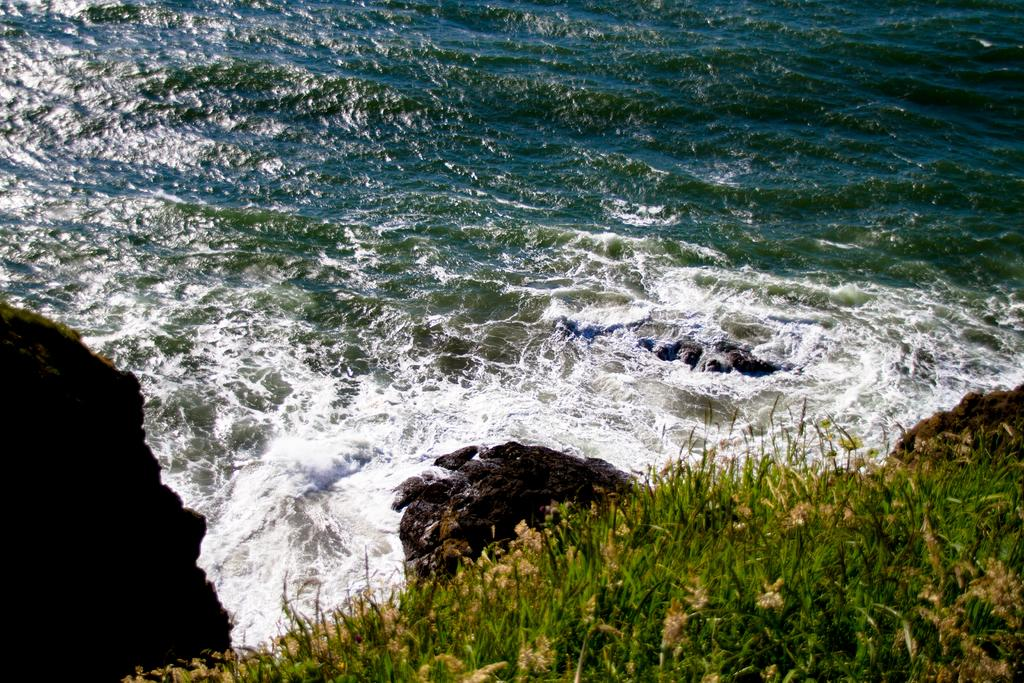What celestial bodies are shown in the image? There are planets depicted in the image. Where are the planets located in the image? The planets are at the bottom of the image. What can be seen in the background of the image? There is water visible in the background of the image. What type of attraction can be seen in the image? There is no attraction present in the image; it features planets and water. What kind of thing is crawling on the planets in the image? There are no things or creatures crawling on the planets in the image; it only depicts planets and water. 